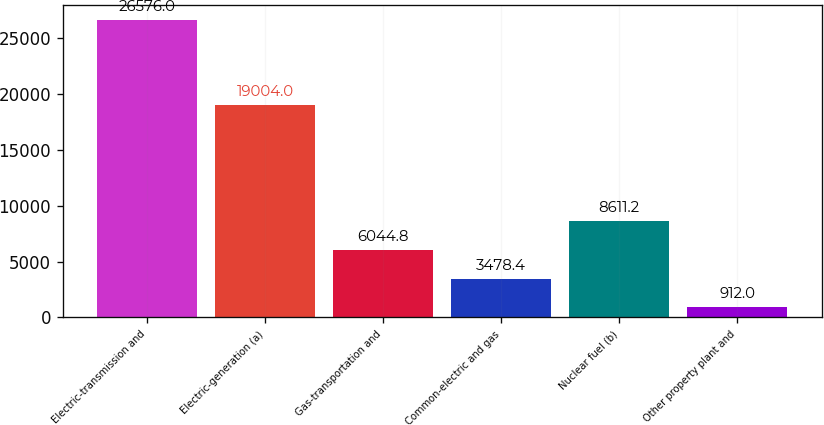Convert chart. <chart><loc_0><loc_0><loc_500><loc_500><bar_chart><fcel>Electric-transmission and<fcel>Electric-generation (a)<fcel>Gas-transportation and<fcel>Common-electric and gas<fcel>Nuclear fuel (b)<fcel>Other property plant and<nl><fcel>26576<fcel>19004<fcel>6044.8<fcel>3478.4<fcel>8611.2<fcel>912<nl></chart> 